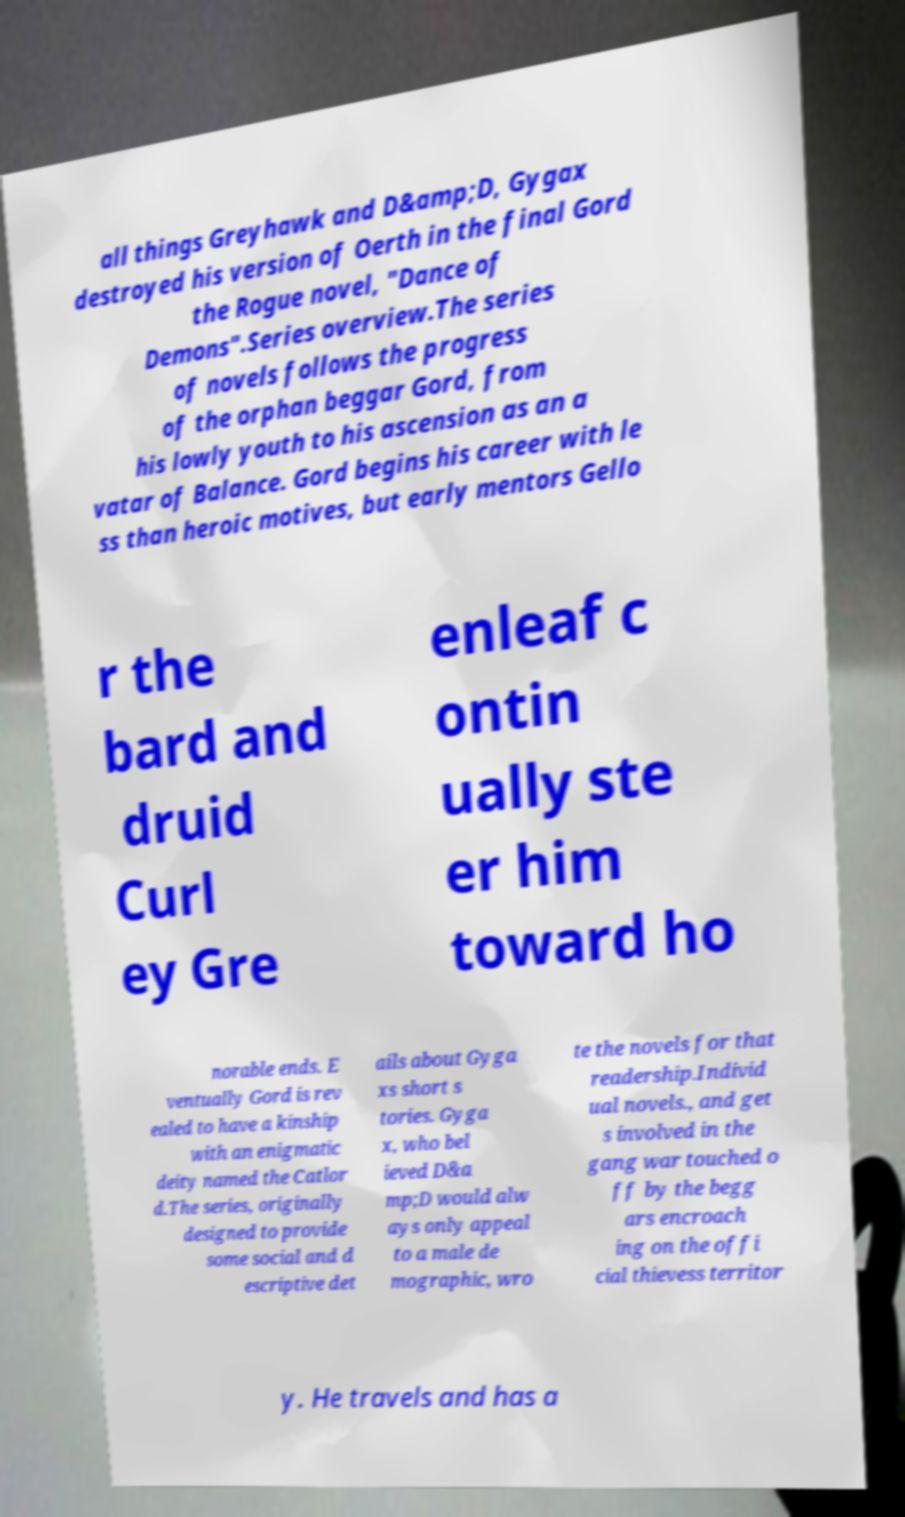Please identify and transcribe the text found in this image. all things Greyhawk and D&amp;D, Gygax destroyed his version of Oerth in the final Gord the Rogue novel, "Dance of Demons".Series overview.The series of novels follows the progress of the orphan beggar Gord, from his lowly youth to his ascension as an a vatar of Balance. Gord begins his career with le ss than heroic motives, but early mentors Gello r the bard and druid Curl ey Gre enleaf c ontin ually ste er him toward ho norable ends. E ventually Gord is rev ealed to have a kinship with an enigmatic deity named the Catlor d.The series, originally designed to provide some social and d escriptive det ails about Gyga xs short s tories. Gyga x, who bel ieved D&a mp;D would alw ays only appeal to a male de mographic, wro te the novels for that readership.Individ ual novels., and get s involved in the gang war touched o ff by the begg ars encroach ing on the offi cial thievess territor y. He travels and has a 